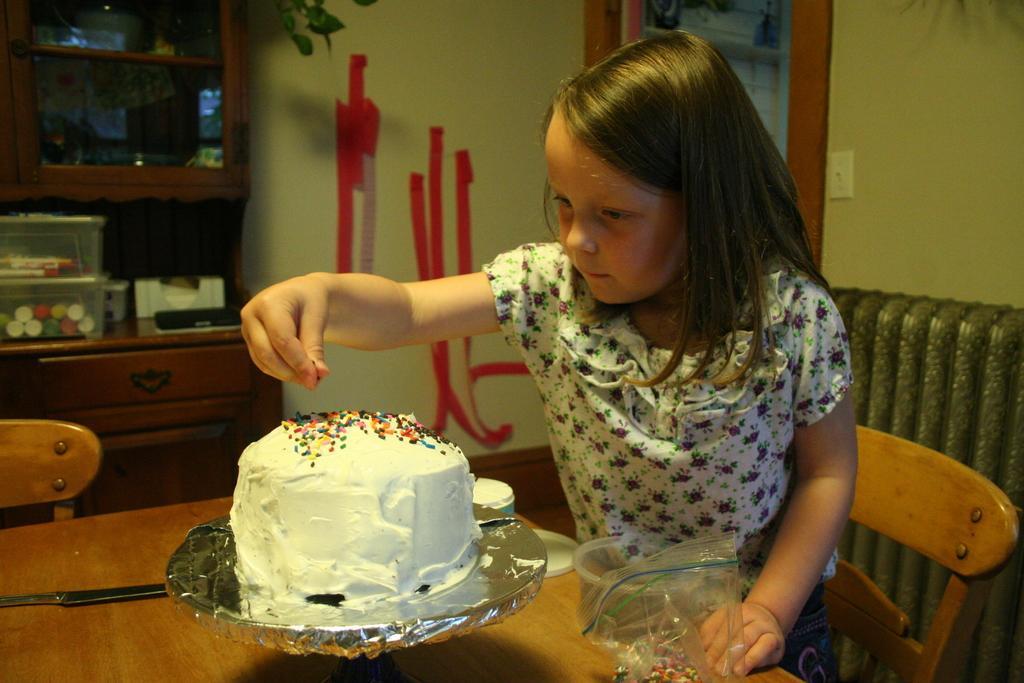Describe this image in one or two sentences. In this image there is a table on that table there is a cake, a child is sitting on the chair near the table, in the background there is a wall and a cupboard. 